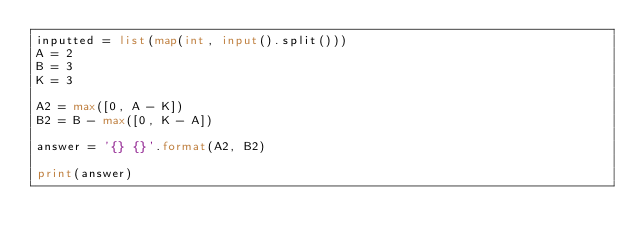<code> <loc_0><loc_0><loc_500><loc_500><_Python_>inputted = list(map(int, input().split()))
A = 2
B = 3
K = 3

A2 = max([0, A - K])
B2 = B - max([0, K - A])

answer = '{} {}'.format(A2, B2)

print(answer)
</code> 